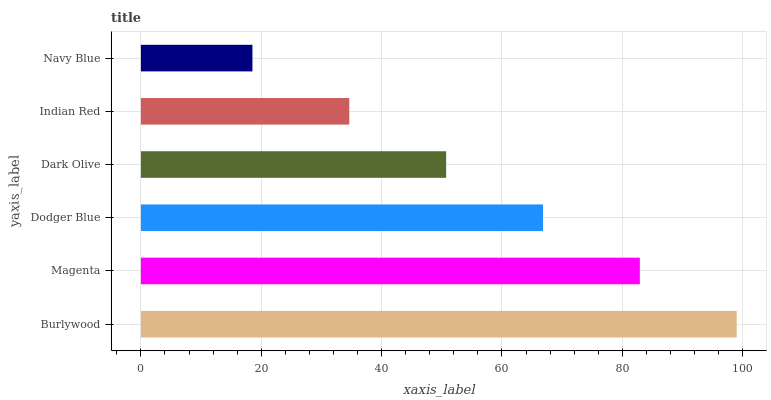Is Navy Blue the minimum?
Answer yes or no. Yes. Is Burlywood the maximum?
Answer yes or no. Yes. Is Magenta the minimum?
Answer yes or no. No. Is Magenta the maximum?
Answer yes or no. No. Is Burlywood greater than Magenta?
Answer yes or no. Yes. Is Magenta less than Burlywood?
Answer yes or no. Yes. Is Magenta greater than Burlywood?
Answer yes or no. No. Is Burlywood less than Magenta?
Answer yes or no. No. Is Dodger Blue the high median?
Answer yes or no. Yes. Is Dark Olive the low median?
Answer yes or no. Yes. Is Navy Blue the high median?
Answer yes or no. No. Is Burlywood the low median?
Answer yes or no. No. 